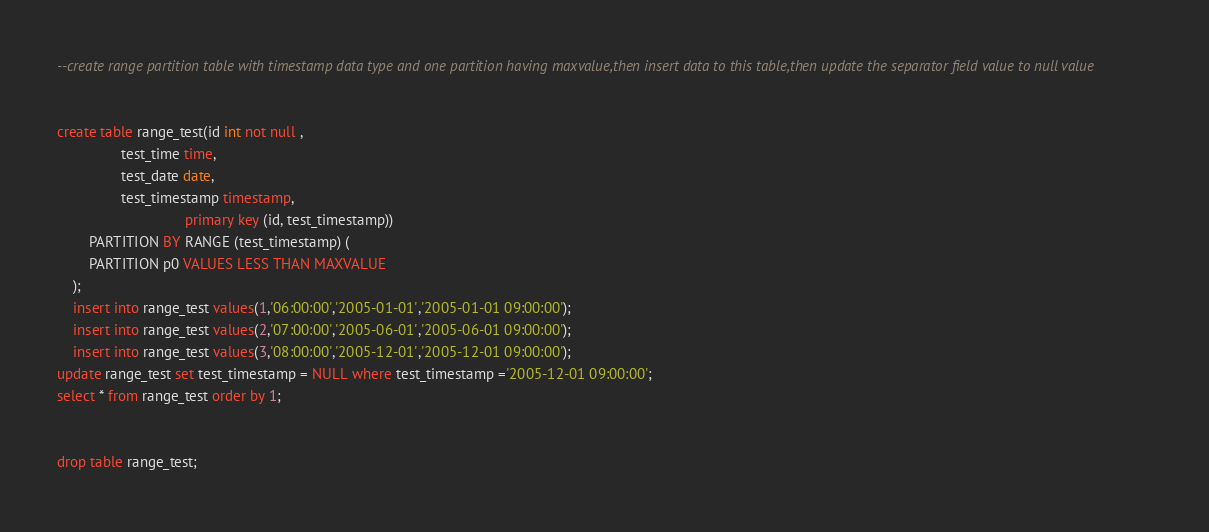<code> <loc_0><loc_0><loc_500><loc_500><_SQL_>--create range partition table with timestamp data type and one partition having maxvalue,then insert data to this table,then update the separator field value to null value


create table range_test(id int not null ,	
				test_time time,
				test_date date,
				test_timestamp timestamp,
                                primary key (id, test_timestamp))
		PARTITION BY RANGE (test_timestamp) (
		PARTITION p0 VALUES LESS THAN MAXVALUE
	);
	insert into range_test values(1,'06:00:00','2005-01-01','2005-01-01 09:00:00');
	insert into range_test values(2,'07:00:00','2005-06-01','2005-06-01 09:00:00');
	insert into range_test values(3,'08:00:00','2005-12-01','2005-12-01 09:00:00');
update range_test set test_timestamp = NULL where test_timestamp ='2005-12-01 09:00:00';
select * from range_test order by 1;


drop table range_test;
</code> 